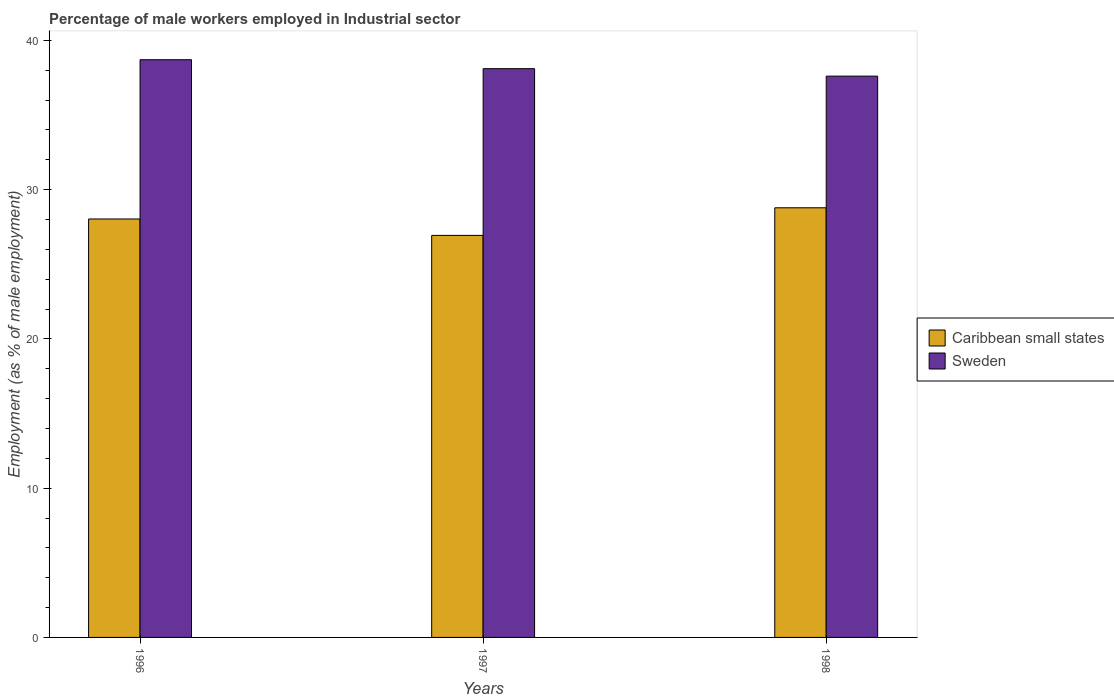How many groups of bars are there?
Provide a short and direct response. 3. How many bars are there on the 2nd tick from the right?
Provide a short and direct response. 2. What is the label of the 2nd group of bars from the left?
Your answer should be compact. 1997. In how many cases, is the number of bars for a given year not equal to the number of legend labels?
Provide a succinct answer. 0. What is the percentage of male workers employed in Industrial sector in Sweden in 1996?
Keep it short and to the point. 38.7. Across all years, what is the maximum percentage of male workers employed in Industrial sector in Sweden?
Offer a very short reply. 38.7. Across all years, what is the minimum percentage of male workers employed in Industrial sector in Caribbean small states?
Your answer should be compact. 26.93. In which year was the percentage of male workers employed in Industrial sector in Caribbean small states minimum?
Your answer should be compact. 1997. What is the total percentage of male workers employed in Industrial sector in Caribbean small states in the graph?
Make the answer very short. 83.74. What is the difference between the percentage of male workers employed in Industrial sector in Caribbean small states in 1996 and that in 1997?
Offer a very short reply. 1.1. What is the difference between the percentage of male workers employed in Industrial sector in Sweden in 1998 and the percentage of male workers employed in Industrial sector in Caribbean small states in 1996?
Offer a terse response. 9.57. What is the average percentage of male workers employed in Industrial sector in Sweden per year?
Provide a succinct answer. 38.13. In the year 1998, what is the difference between the percentage of male workers employed in Industrial sector in Sweden and percentage of male workers employed in Industrial sector in Caribbean small states?
Ensure brevity in your answer.  8.82. What is the ratio of the percentage of male workers employed in Industrial sector in Sweden in 1996 to that in 1997?
Keep it short and to the point. 1.02. Is the percentage of male workers employed in Industrial sector in Sweden in 1997 less than that in 1998?
Provide a short and direct response. No. What is the difference between the highest and the second highest percentage of male workers employed in Industrial sector in Sweden?
Your answer should be compact. 0.6. What is the difference between the highest and the lowest percentage of male workers employed in Industrial sector in Sweden?
Ensure brevity in your answer.  1.1. In how many years, is the percentage of male workers employed in Industrial sector in Sweden greater than the average percentage of male workers employed in Industrial sector in Sweden taken over all years?
Keep it short and to the point. 1. Is the sum of the percentage of male workers employed in Industrial sector in Caribbean small states in 1996 and 1997 greater than the maximum percentage of male workers employed in Industrial sector in Sweden across all years?
Give a very brief answer. Yes. How many bars are there?
Ensure brevity in your answer.  6. Are all the bars in the graph horizontal?
Your answer should be very brief. No. How many years are there in the graph?
Make the answer very short. 3. Are the values on the major ticks of Y-axis written in scientific E-notation?
Provide a short and direct response. No. Does the graph contain any zero values?
Your answer should be compact. No. Where does the legend appear in the graph?
Keep it short and to the point. Center right. What is the title of the graph?
Keep it short and to the point. Percentage of male workers employed in Industrial sector. Does "Rwanda" appear as one of the legend labels in the graph?
Provide a short and direct response. No. What is the label or title of the X-axis?
Give a very brief answer. Years. What is the label or title of the Y-axis?
Ensure brevity in your answer.  Employment (as % of male employment). What is the Employment (as % of male employment) of Caribbean small states in 1996?
Make the answer very short. 28.03. What is the Employment (as % of male employment) of Sweden in 1996?
Provide a short and direct response. 38.7. What is the Employment (as % of male employment) of Caribbean small states in 1997?
Make the answer very short. 26.93. What is the Employment (as % of male employment) in Sweden in 1997?
Give a very brief answer. 38.1. What is the Employment (as % of male employment) in Caribbean small states in 1998?
Provide a short and direct response. 28.78. What is the Employment (as % of male employment) of Sweden in 1998?
Your answer should be very brief. 37.6. Across all years, what is the maximum Employment (as % of male employment) of Caribbean small states?
Your answer should be compact. 28.78. Across all years, what is the maximum Employment (as % of male employment) of Sweden?
Offer a very short reply. 38.7. Across all years, what is the minimum Employment (as % of male employment) of Caribbean small states?
Your answer should be compact. 26.93. Across all years, what is the minimum Employment (as % of male employment) of Sweden?
Your response must be concise. 37.6. What is the total Employment (as % of male employment) in Caribbean small states in the graph?
Your answer should be compact. 83.74. What is the total Employment (as % of male employment) of Sweden in the graph?
Your answer should be very brief. 114.4. What is the difference between the Employment (as % of male employment) of Caribbean small states in 1996 and that in 1997?
Your answer should be compact. 1.1. What is the difference between the Employment (as % of male employment) of Sweden in 1996 and that in 1997?
Ensure brevity in your answer.  0.6. What is the difference between the Employment (as % of male employment) in Caribbean small states in 1996 and that in 1998?
Your answer should be compact. -0.75. What is the difference between the Employment (as % of male employment) in Sweden in 1996 and that in 1998?
Keep it short and to the point. 1.1. What is the difference between the Employment (as % of male employment) in Caribbean small states in 1997 and that in 1998?
Your answer should be very brief. -1.85. What is the difference between the Employment (as % of male employment) of Caribbean small states in 1996 and the Employment (as % of male employment) of Sweden in 1997?
Give a very brief answer. -10.07. What is the difference between the Employment (as % of male employment) in Caribbean small states in 1996 and the Employment (as % of male employment) in Sweden in 1998?
Provide a succinct answer. -9.57. What is the difference between the Employment (as % of male employment) in Caribbean small states in 1997 and the Employment (as % of male employment) in Sweden in 1998?
Make the answer very short. -10.67. What is the average Employment (as % of male employment) in Caribbean small states per year?
Your answer should be compact. 27.91. What is the average Employment (as % of male employment) of Sweden per year?
Ensure brevity in your answer.  38.13. In the year 1996, what is the difference between the Employment (as % of male employment) in Caribbean small states and Employment (as % of male employment) in Sweden?
Give a very brief answer. -10.67. In the year 1997, what is the difference between the Employment (as % of male employment) of Caribbean small states and Employment (as % of male employment) of Sweden?
Your answer should be compact. -11.17. In the year 1998, what is the difference between the Employment (as % of male employment) in Caribbean small states and Employment (as % of male employment) in Sweden?
Give a very brief answer. -8.82. What is the ratio of the Employment (as % of male employment) of Caribbean small states in 1996 to that in 1997?
Provide a succinct answer. 1.04. What is the ratio of the Employment (as % of male employment) in Sweden in 1996 to that in 1997?
Offer a terse response. 1.02. What is the ratio of the Employment (as % of male employment) of Caribbean small states in 1996 to that in 1998?
Provide a short and direct response. 0.97. What is the ratio of the Employment (as % of male employment) in Sweden in 1996 to that in 1998?
Keep it short and to the point. 1.03. What is the ratio of the Employment (as % of male employment) of Caribbean small states in 1997 to that in 1998?
Your answer should be compact. 0.94. What is the ratio of the Employment (as % of male employment) in Sweden in 1997 to that in 1998?
Make the answer very short. 1.01. What is the difference between the highest and the second highest Employment (as % of male employment) of Caribbean small states?
Offer a very short reply. 0.75. What is the difference between the highest and the lowest Employment (as % of male employment) of Caribbean small states?
Your answer should be very brief. 1.85. What is the difference between the highest and the lowest Employment (as % of male employment) of Sweden?
Make the answer very short. 1.1. 